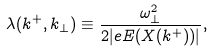<formula> <loc_0><loc_0><loc_500><loc_500>\lambda ( k ^ { + } , k _ { \bot } ) \equiv \frac { \omega _ { \bot } ^ { 2 } } { 2 | e E ( X ( k ^ { + } ) ) | } ,</formula> 